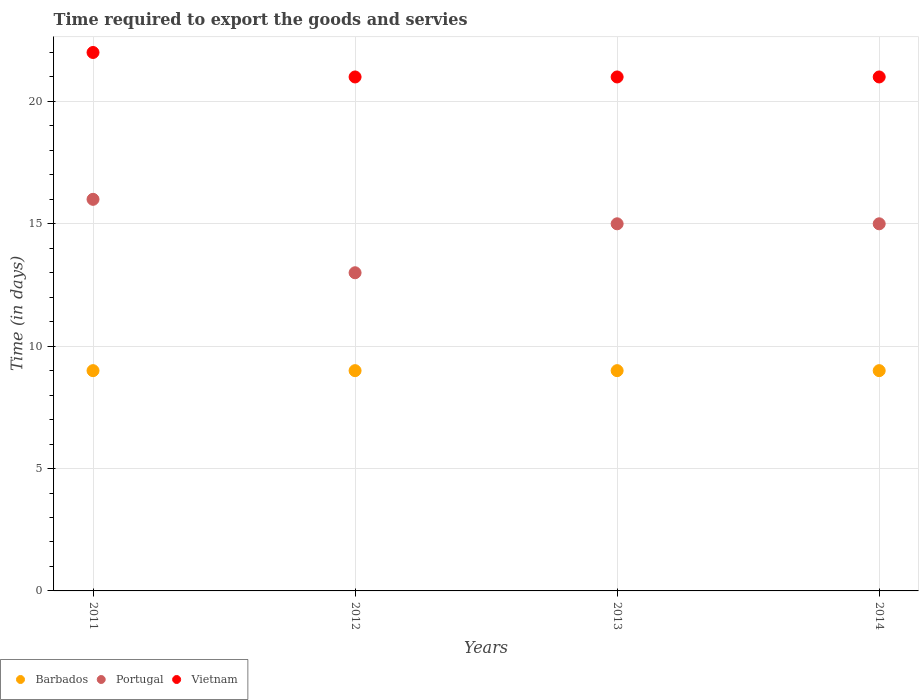Is the number of dotlines equal to the number of legend labels?
Provide a succinct answer. Yes. What is the number of days required to export the goods and services in Barbados in 2014?
Provide a short and direct response. 9. Across all years, what is the maximum number of days required to export the goods and services in Barbados?
Offer a terse response. 9. Across all years, what is the minimum number of days required to export the goods and services in Portugal?
Offer a very short reply. 13. In which year was the number of days required to export the goods and services in Vietnam minimum?
Your answer should be very brief. 2012. What is the total number of days required to export the goods and services in Barbados in the graph?
Ensure brevity in your answer.  36. What is the difference between the number of days required to export the goods and services in Portugal in 2011 and that in 2013?
Ensure brevity in your answer.  1. What is the difference between the number of days required to export the goods and services in Vietnam in 2011 and the number of days required to export the goods and services in Portugal in 2013?
Your answer should be compact. 7. What is the average number of days required to export the goods and services in Portugal per year?
Your response must be concise. 14.75. In the year 2014, what is the difference between the number of days required to export the goods and services in Barbados and number of days required to export the goods and services in Portugal?
Your answer should be compact. -6. What is the ratio of the number of days required to export the goods and services in Vietnam in 2012 to that in 2014?
Ensure brevity in your answer.  1. Is the number of days required to export the goods and services in Vietnam in 2011 less than that in 2012?
Provide a short and direct response. No. Is the difference between the number of days required to export the goods and services in Barbados in 2012 and 2014 greater than the difference between the number of days required to export the goods and services in Portugal in 2012 and 2014?
Provide a succinct answer. Yes. What is the difference between the highest and the lowest number of days required to export the goods and services in Vietnam?
Keep it short and to the point. 1. Is it the case that in every year, the sum of the number of days required to export the goods and services in Barbados and number of days required to export the goods and services in Vietnam  is greater than the number of days required to export the goods and services in Portugal?
Your answer should be compact. Yes. Is the number of days required to export the goods and services in Barbados strictly greater than the number of days required to export the goods and services in Portugal over the years?
Offer a very short reply. No. How many years are there in the graph?
Provide a short and direct response. 4. Does the graph contain any zero values?
Ensure brevity in your answer.  No. Does the graph contain grids?
Ensure brevity in your answer.  Yes. How are the legend labels stacked?
Your answer should be very brief. Horizontal. What is the title of the graph?
Your answer should be compact. Time required to export the goods and servies. What is the label or title of the X-axis?
Keep it short and to the point. Years. What is the label or title of the Y-axis?
Ensure brevity in your answer.  Time (in days). What is the Time (in days) of Portugal in 2011?
Make the answer very short. 16. What is the Time (in days) of Barbados in 2012?
Ensure brevity in your answer.  9. What is the Time (in days) in Portugal in 2012?
Provide a short and direct response. 13. What is the Time (in days) in Vietnam in 2012?
Give a very brief answer. 21. What is the Time (in days) in Barbados in 2013?
Your response must be concise. 9. What is the Time (in days) of Portugal in 2013?
Provide a succinct answer. 15. What is the Time (in days) of Vietnam in 2013?
Provide a short and direct response. 21. What is the Time (in days) in Barbados in 2014?
Offer a terse response. 9. Across all years, what is the maximum Time (in days) of Barbados?
Keep it short and to the point. 9. Across all years, what is the maximum Time (in days) of Vietnam?
Offer a terse response. 22. Across all years, what is the minimum Time (in days) of Barbados?
Offer a very short reply. 9. Across all years, what is the minimum Time (in days) in Portugal?
Your answer should be compact. 13. Across all years, what is the minimum Time (in days) in Vietnam?
Offer a terse response. 21. What is the total Time (in days) of Portugal in the graph?
Your answer should be compact. 59. What is the difference between the Time (in days) in Portugal in 2011 and that in 2012?
Give a very brief answer. 3. What is the difference between the Time (in days) of Vietnam in 2011 and that in 2012?
Give a very brief answer. 1. What is the difference between the Time (in days) in Barbados in 2011 and that in 2013?
Give a very brief answer. 0. What is the difference between the Time (in days) of Barbados in 2011 and that in 2014?
Provide a succinct answer. 0. What is the difference between the Time (in days) of Vietnam in 2011 and that in 2014?
Provide a short and direct response. 1. What is the difference between the Time (in days) in Barbados in 2012 and that in 2013?
Your answer should be compact. 0. What is the difference between the Time (in days) in Portugal in 2012 and that in 2013?
Ensure brevity in your answer.  -2. What is the difference between the Time (in days) in Barbados in 2012 and that in 2014?
Ensure brevity in your answer.  0. What is the difference between the Time (in days) in Portugal in 2012 and that in 2014?
Provide a short and direct response. -2. What is the difference between the Time (in days) of Portugal in 2013 and that in 2014?
Ensure brevity in your answer.  0. What is the difference between the Time (in days) in Vietnam in 2013 and that in 2014?
Your response must be concise. 0. What is the difference between the Time (in days) of Barbados in 2011 and the Time (in days) of Vietnam in 2012?
Give a very brief answer. -12. What is the difference between the Time (in days) in Barbados in 2011 and the Time (in days) in Vietnam in 2013?
Offer a terse response. -12. What is the difference between the Time (in days) in Portugal in 2011 and the Time (in days) in Vietnam in 2013?
Provide a short and direct response. -5. What is the difference between the Time (in days) of Barbados in 2011 and the Time (in days) of Portugal in 2014?
Offer a terse response. -6. What is the difference between the Time (in days) of Barbados in 2011 and the Time (in days) of Vietnam in 2014?
Provide a succinct answer. -12. What is the difference between the Time (in days) of Barbados in 2012 and the Time (in days) of Portugal in 2013?
Your answer should be compact. -6. What is the difference between the Time (in days) of Barbados in 2012 and the Time (in days) of Vietnam in 2013?
Your answer should be compact. -12. What is the difference between the Time (in days) in Barbados in 2012 and the Time (in days) in Portugal in 2014?
Make the answer very short. -6. What is the difference between the Time (in days) in Barbados in 2013 and the Time (in days) in Portugal in 2014?
Your answer should be very brief. -6. What is the average Time (in days) in Portugal per year?
Keep it short and to the point. 14.75. What is the average Time (in days) in Vietnam per year?
Offer a terse response. 21.25. In the year 2011, what is the difference between the Time (in days) of Barbados and Time (in days) of Portugal?
Offer a terse response. -7. In the year 2011, what is the difference between the Time (in days) of Portugal and Time (in days) of Vietnam?
Offer a terse response. -6. In the year 2012, what is the difference between the Time (in days) of Barbados and Time (in days) of Vietnam?
Offer a terse response. -12. In the year 2013, what is the difference between the Time (in days) of Barbados and Time (in days) of Vietnam?
Provide a short and direct response. -12. In the year 2013, what is the difference between the Time (in days) in Portugal and Time (in days) in Vietnam?
Offer a terse response. -6. In the year 2014, what is the difference between the Time (in days) of Portugal and Time (in days) of Vietnam?
Offer a terse response. -6. What is the ratio of the Time (in days) of Barbados in 2011 to that in 2012?
Ensure brevity in your answer.  1. What is the ratio of the Time (in days) in Portugal in 2011 to that in 2012?
Provide a succinct answer. 1.23. What is the ratio of the Time (in days) of Vietnam in 2011 to that in 2012?
Give a very brief answer. 1.05. What is the ratio of the Time (in days) in Barbados in 2011 to that in 2013?
Your answer should be compact. 1. What is the ratio of the Time (in days) in Portugal in 2011 to that in 2013?
Provide a succinct answer. 1.07. What is the ratio of the Time (in days) of Vietnam in 2011 to that in 2013?
Keep it short and to the point. 1.05. What is the ratio of the Time (in days) of Portugal in 2011 to that in 2014?
Offer a very short reply. 1.07. What is the ratio of the Time (in days) of Vietnam in 2011 to that in 2014?
Offer a very short reply. 1.05. What is the ratio of the Time (in days) of Portugal in 2012 to that in 2013?
Provide a succinct answer. 0.87. What is the ratio of the Time (in days) of Barbados in 2012 to that in 2014?
Make the answer very short. 1. What is the ratio of the Time (in days) in Portugal in 2012 to that in 2014?
Ensure brevity in your answer.  0.87. What is the ratio of the Time (in days) in Barbados in 2013 to that in 2014?
Ensure brevity in your answer.  1. What is the ratio of the Time (in days) of Portugal in 2013 to that in 2014?
Your response must be concise. 1. What is the ratio of the Time (in days) in Vietnam in 2013 to that in 2014?
Provide a succinct answer. 1. What is the difference between the highest and the second highest Time (in days) of Barbados?
Ensure brevity in your answer.  0. What is the difference between the highest and the lowest Time (in days) of Vietnam?
Offer a very short reply. 1. 